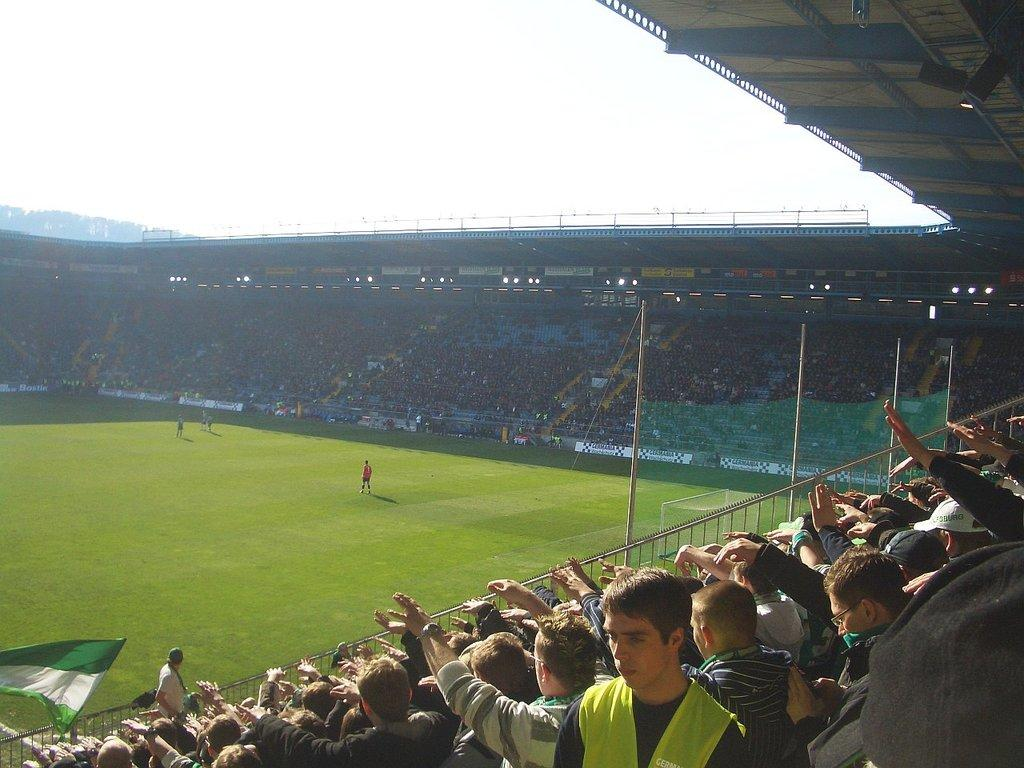How many people are in the image? There is a group of people in the image, but the exact number cannot be determined from the provided facts. What are the people in the image doing? The facts do not specify what the people are doing, but we know that some of them are standing on the ground. What can be seen in the image besides the people? There is a flag, poles, lights, grass, and the sky visible in the image. What is the background of the image? The sky is visible in the background of the image. What type of wire is being used to hold up the existence in the image? There is no mention of an "existence" in the image, and no wire is visible. The image features a group of people, a flag, poles, lights, grass, and the sky. 